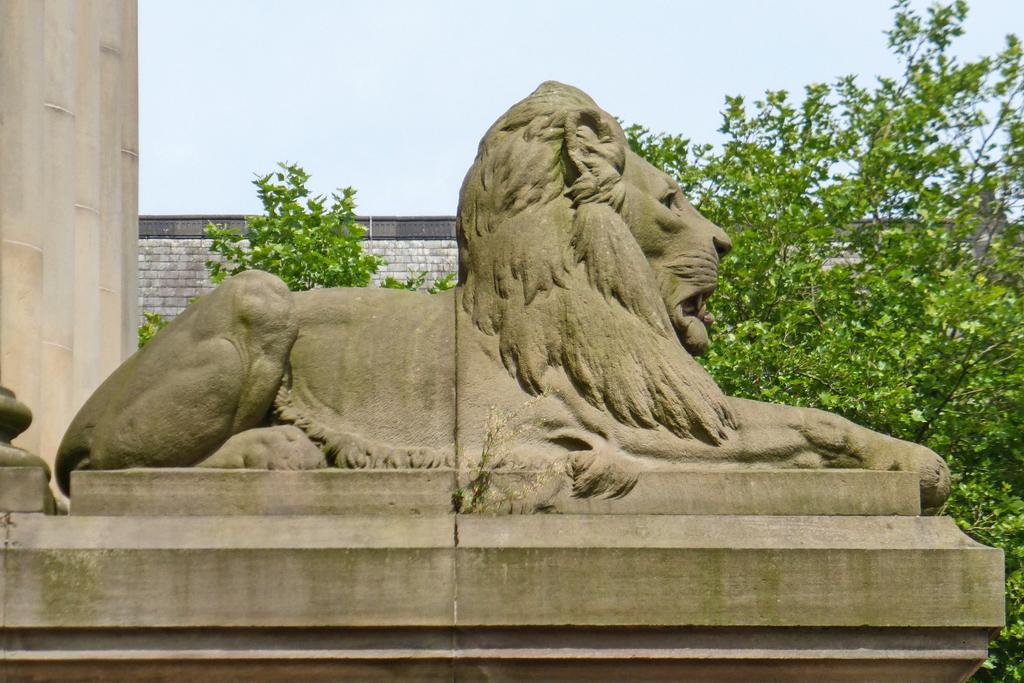What type of animal is depicted in the sculpture on the wall? There is a sculpture of a lion on the wall. What is located behind the lion sculpture? There are plants behind the lion sculpture. What can be seen in the background of the image? There is a wall in the background, and the sky is visible at the top of the image. What architectural feature is present on the left side of the image? There are pillars to the left of the image. What type of stew is being served to the visitor in the image? There is no visitor or stew present in the image. 